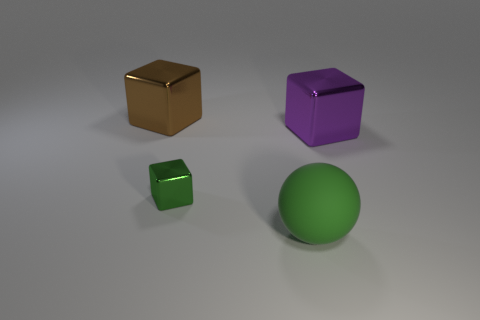There is a large cube on the left side of the green thing right of the green thing that is behind the large green ball; what is it made of?
Ensure brevity in your answer.  Metal. Is the material of the big green object the same as the purple thing that is on the right side of the rubber sphere?
Offer a very short reply. No. What is the material of the big brown thing that is the same shape as the large purple object?
Your answer should be compact. Metal. Is there any other thing that is made of the same material as the brown object?
Your answer should be very brief. Yes. Is the number of big brown cubes that are to the left of the purple shiny thing greater than the number of large purple metal blocks on the right side of the large brown block?
Ensure brevity in your answer.  No. What is the shape of the brown thing that is made of the same material as the small green block?
Provide a short and direct response. Cube. What number of other things are the same shape as the brown object?
Provide a short and direct response. 2. There is a big shiny object right of the small green metallic thing; what shape is it?
Make the answer very short. Cube. The sphere is what color?
Keep it short and to the point. Green. How many other things are the same size as the purple object?
Make the answer very short. 2. 